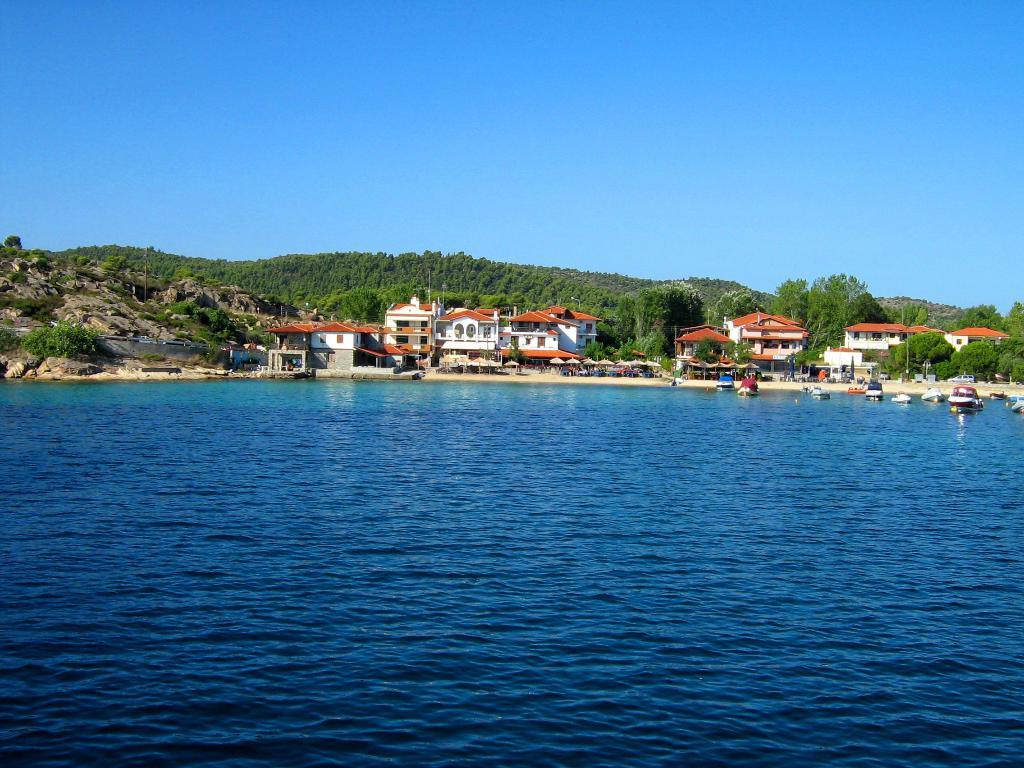What type of structures can be seen in the image? There are buildings in the image. What else can be seen in the image besides buildings? There are poles, trees, and boats on the water surface in the image. What is the color of the sky in the image? The sky is blue in the image. Can you see a beetle crawling on the boat in the image? There is no beetle present in the image; it only features buildings, poles, trees, boats, and a blue sky. 